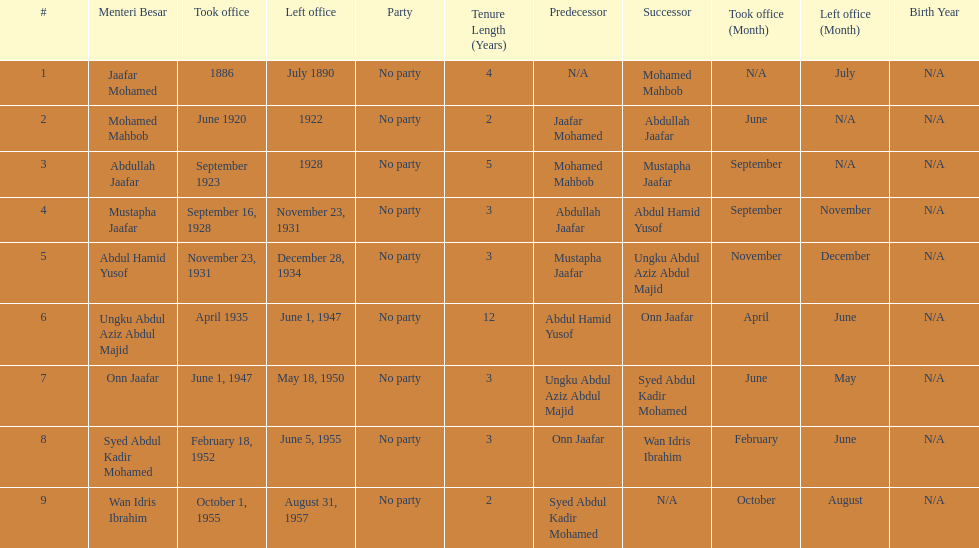What is the number of menteri besars that there have been during the pre-independence period? 9. 